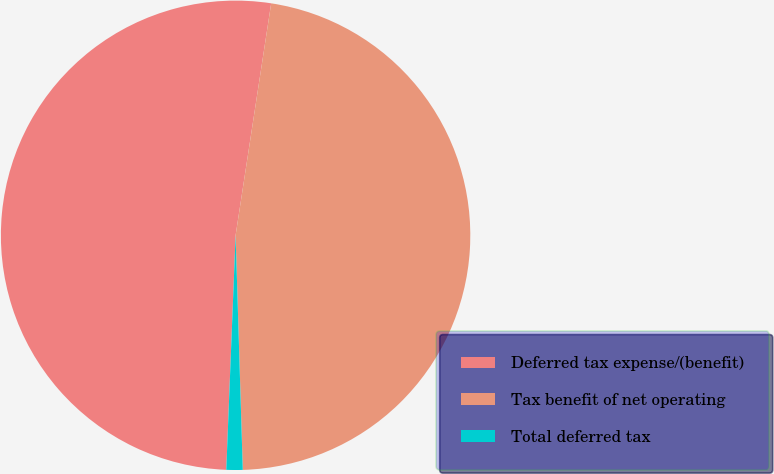Convert chart. <chart><loc_0><loc_0><loc_500><loc_500><pie_chart><fcel>Deferred tax expense/(benefit)<fcel>Tax benefit of net operating<fcel>Total deferred tax<nl><fcel>51.79%<fcel>47.09%<fcel>1.12%<nl></chart> 